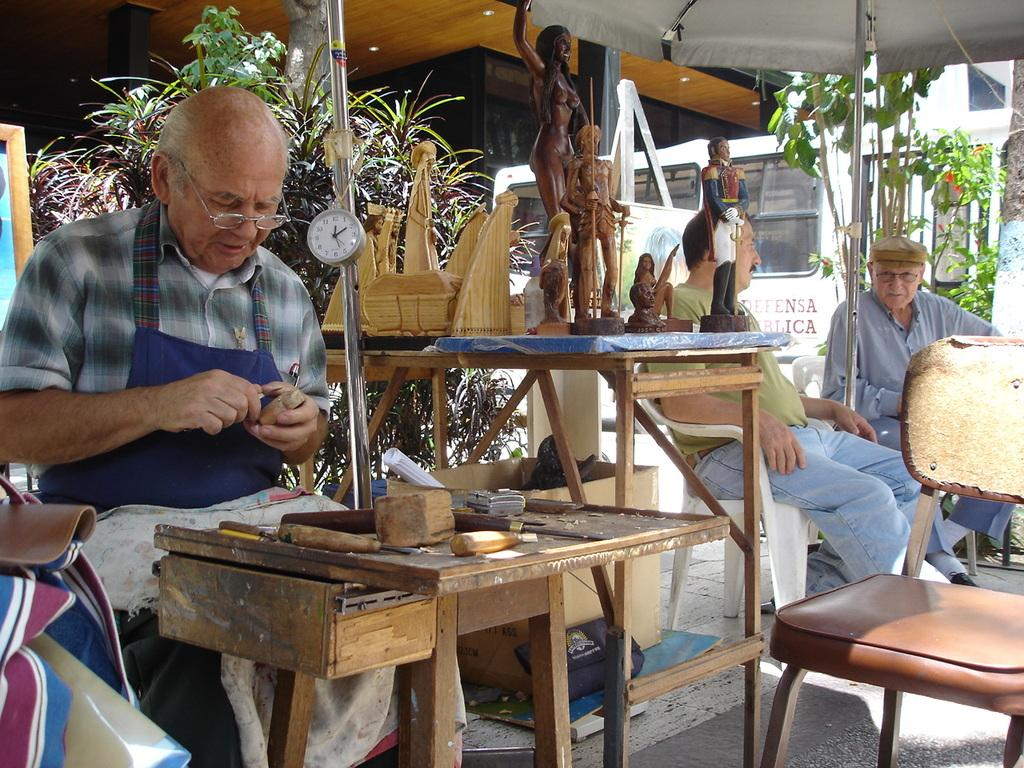Who is the main subject in the image? There is an old man in the image. What is the old man doing in the image? The old man is sitting and crafting a wooden piece. Are there any other people in the image? Yes, there are two men in the image. How are the two men positioned in relation to the old man? The two men are at a distance from the old man. What type of ornament is the old man using to write on the wooden piece? There is no ornament or writing present in the image; the old man is simply crafting a wooden piece. 